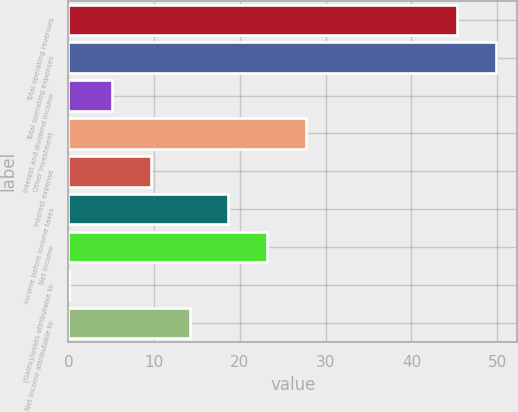Convert chart to OTSL. <chart><loc_0><loc_0><loc_500><loc_500><bar_chart><fcel>Total operating revenues<fcel>Total operating expenses<fcel>Interest and dividend income<fcel>Other investment<fcel>Interest expense<fcel>Income before income taxes<fcel>Net income<fcel>(Gains)/losses attributable to<fcel>Net income attributable to<nl><fcel>45.3<fcel>49.82<fcel>5.1<fcel>27.7<fcel>9.62<fcel>18.66<fcel>23.18<fcel>0.1<fcel>14.14<nl></chart> 